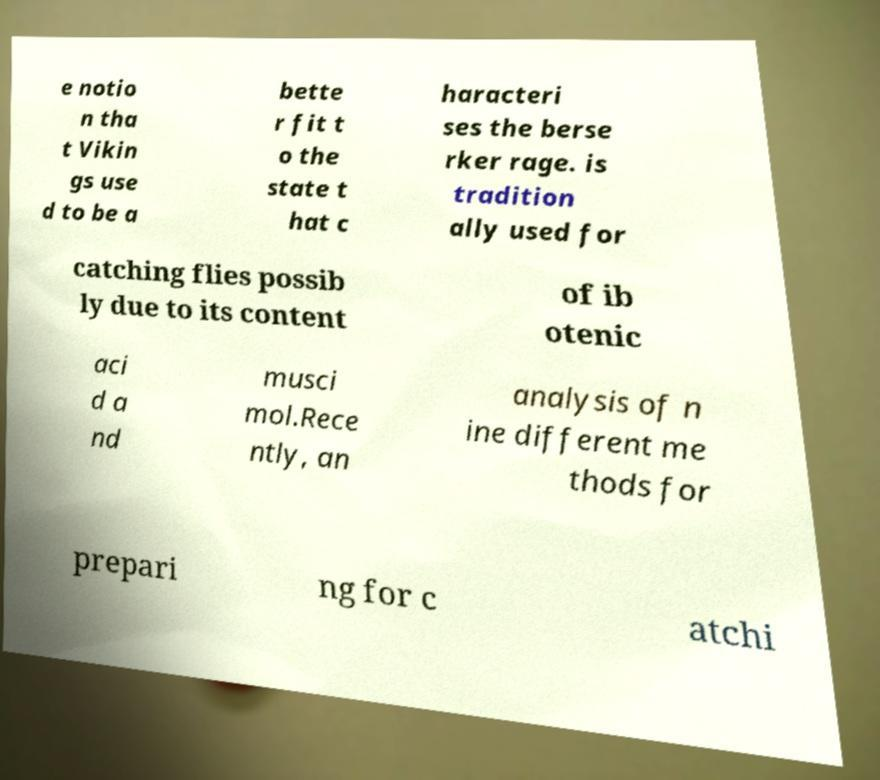What messages or text are displayed in this image? I need them in a readable, typed format. e notio n tha t Vikin gs use d to be a bette r fit t o the state t hat c haracteri ses the berse rker rage. is tradition ally used for catching flies possib ly due to its content of ib otenic aci d a nd musci mol.Rece ntly, an analysis of n ine different me thods for prepari ng for c atchi 